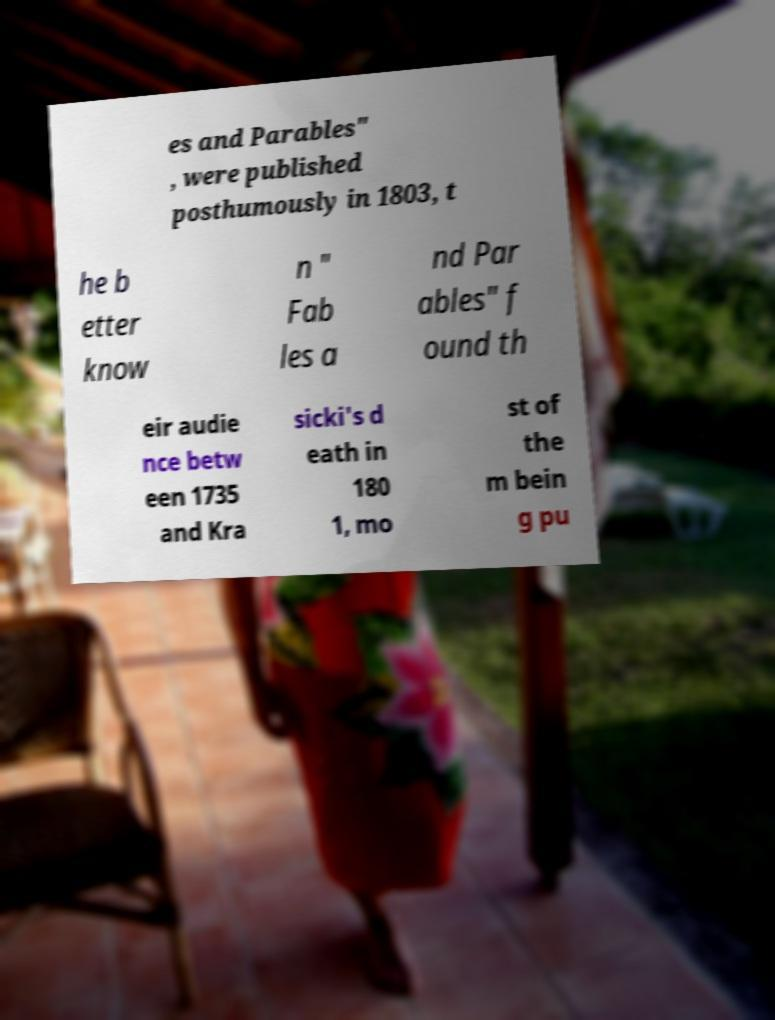For documentation purposes, I need the text within this image transcribed. Could you provide that? es and Parables" , were published posthumously in 1803, t he b etter know n " Fab les a nd Par ables" f ound th eir audie nce betw een 1735 and Kra sicki's d eath in 180 1, mo st of the m bein g pu 